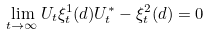Convert formula to latex. <formula><loc_0><loc_0><loc_500><loc_500>\lim _ { t \to \infty } U _ { t } \xi ^ { 1 } _ { t } ( d ) U _ { t } ^ { * } - \xi ^ { 2 } _ { t } ( d ) = 0</formula> 